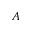Convert formula to latex. <formula><loc_0><loc_0><loc_500><loc_500>A</formula> 